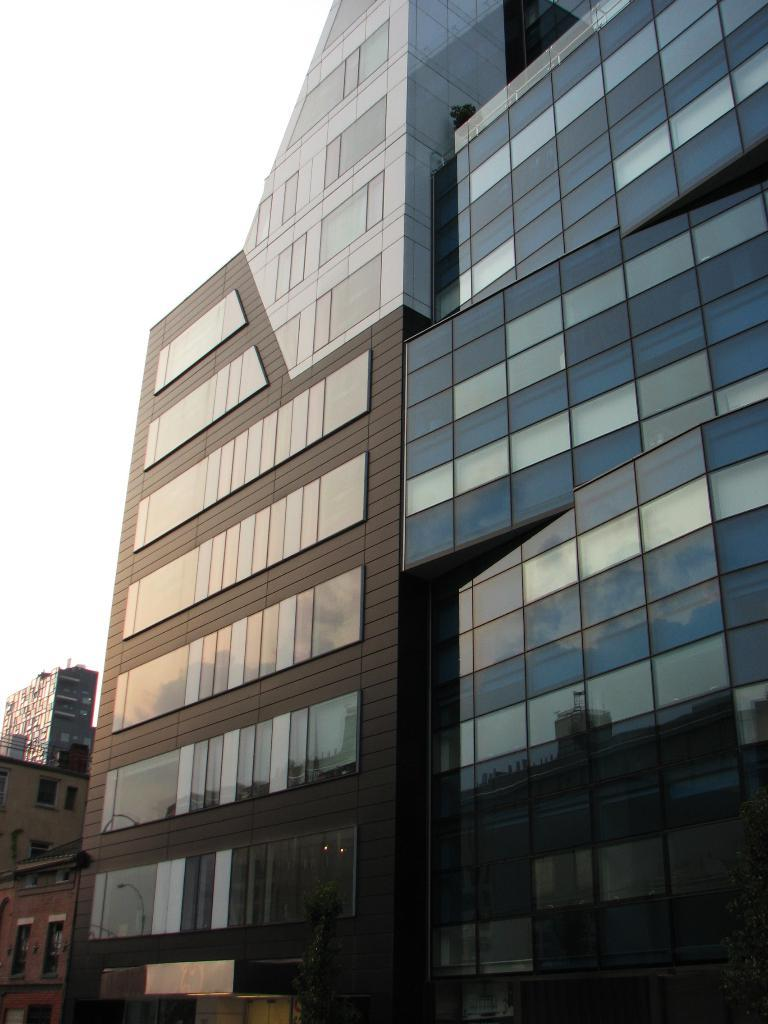What type of structures can be seen in the image? There are buildings with windows in the image. What else is present in the image besides the buildings? There are objects in the image. What can be seen in the background of the image? The sky is visible in the background of the image. What type of verse can be heard recited by the flame in the image? There is no flame present in the image, and therefore no verse can be heard. 